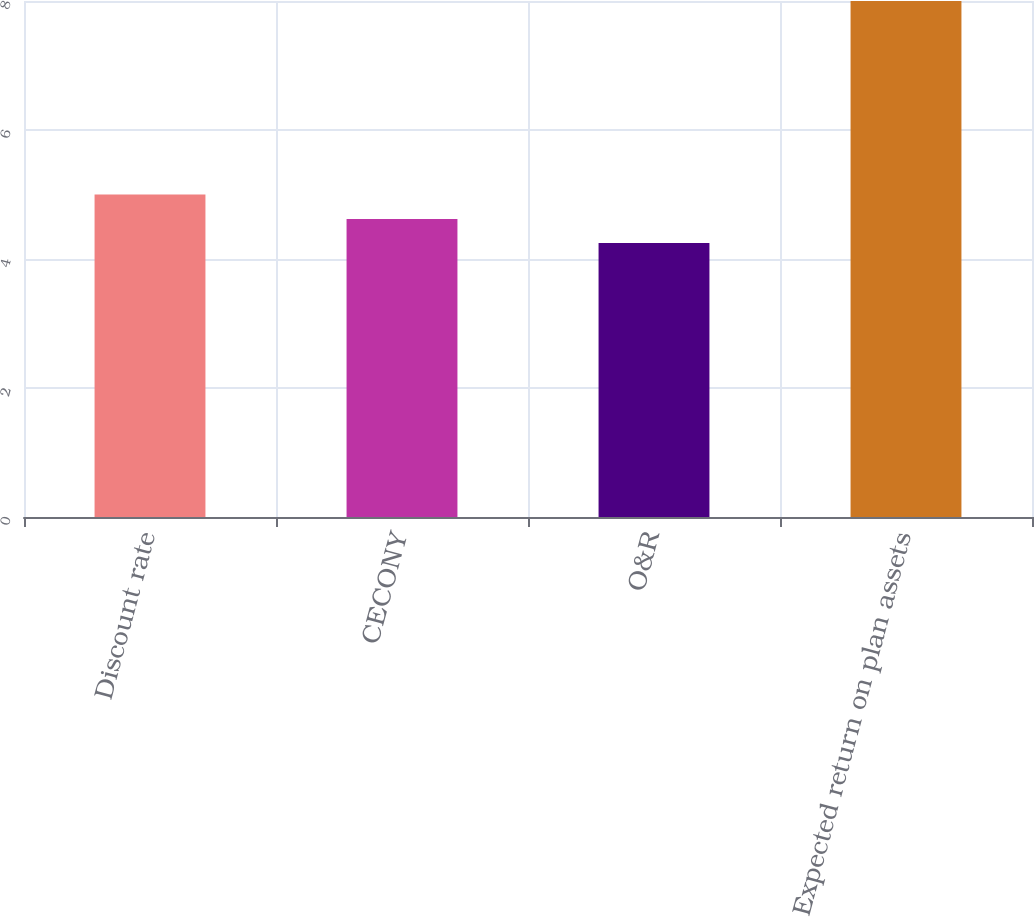Convert chart to OTSL. <chart><loc_0><loc_0><loc_500><loc_500><bar_chart><fcel>Discount rate<fcel>CECONY<fcel>O&R<fcel>Expected return on plan assets<nl><fcel>5<fcel>4.62<fcel>4.25<fcel>8<nl></chart> 